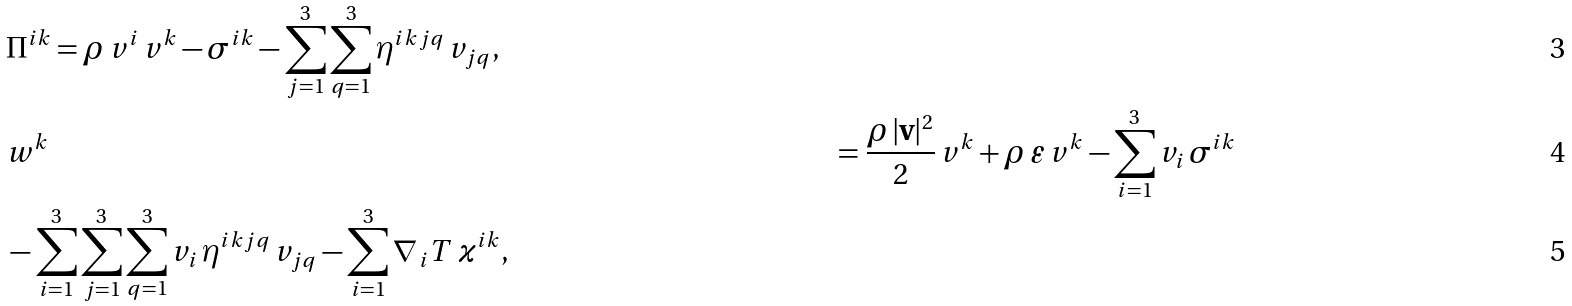<formula> <loc_0><loc_0><loc_500><loc_500>& \Pi ^ { i k } = \rho \, v ^ { i } \, v ^ { k } - \sigma ^ { i k } - \sum ^ { 3 } _ { j = 1 } \sum ^ { 3 } _ { q = 1 } \eta ^ { i k j q } \, v _ { j q } , \\ & w ^ { k } & = \frac { \rho \, | \mathbf v | ^ { 2 } } { 2 } \, v ^ { k } + \rho \, \varepsilon \, v ^ { k } - \sum ^ { 3 } _ { i = 1 } v _ { i } \, \sigma ^ { i k } \\ & - \sum ^ { 3 } _ { i = 1 } \sum ^ { 3 } _ { j = 1 } \sum ^ { 3 } _ { q = 1 } v _ { i } \, \eta ^ { i k j q } \, v _ { j q } - \sum ^ { 3 } _ { i = 1 } \nabla _ { \, i } T \, \varkappa ^ { i k } ,</formula> 